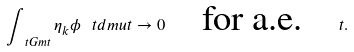Convert formula to latex. <formula><loc_0><loc_0><loc_500><loc_500>\int _ { \ t G m t } \eta _ { k } \phi \, \ t d m u t \to 0 \quad \text {for a.e.} \quad t .</formula> 